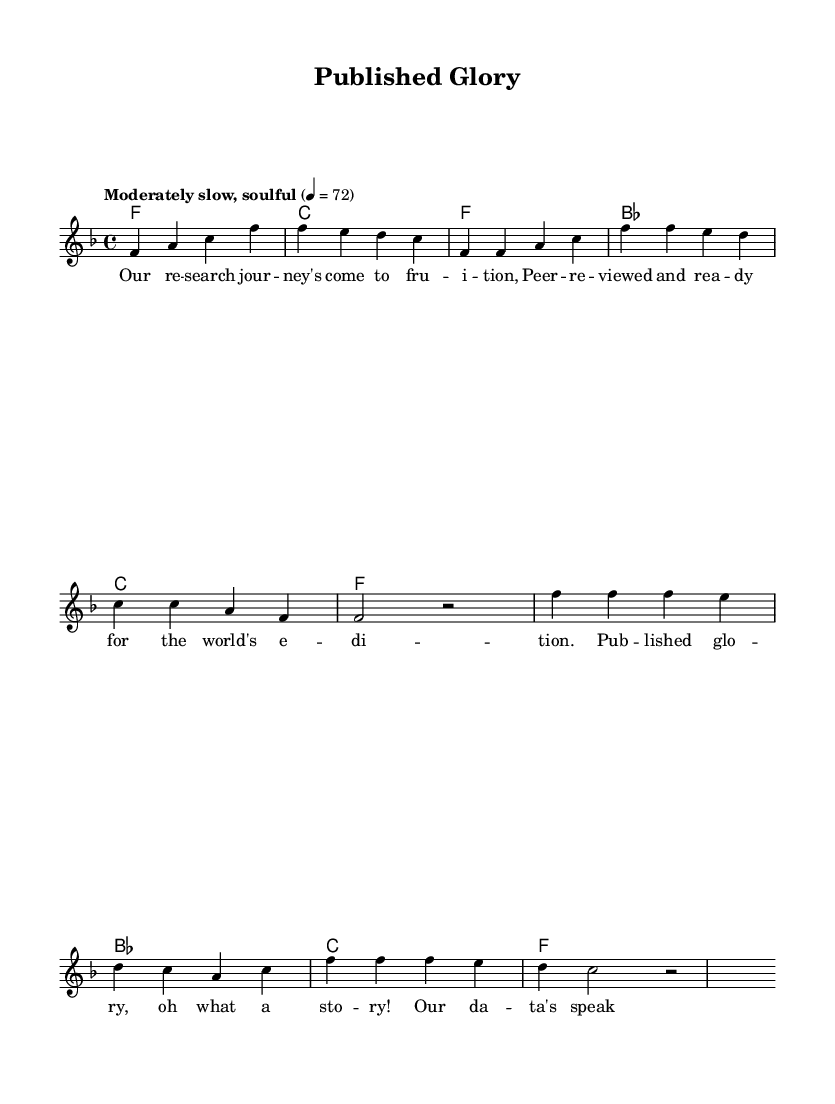What is the key signature of this music? The key signature is F major, indicated by a single flat (B flat) on the staff.
Answer: F major What is the time signature? The time signature is 4/4, meaning there are four beats in each measure.
Answer: 4/4 What is the tempo marking? The tempo marking states "Moderately slow, soulful," which suggests a relaxed but soulful pace for the music.
Answer: Moderately slow, soulful How many measures are in the chorus section? In the sheet music, the chorus consists of two measures as indicated in the corresponding section.
Answer: 2 measures Which chord follows the first measure of the verse? The chord that follows the first measure of the verse is B flat major, which is indicated next in the harmonies.
Answer: B flat major What is the main theme of the lyrics? The main theme of the lyrics revolves around achieving publication and the joy of successful research, as seen in phrases expressing celebrate glory and knowledge gained.
Answer: Published glory How many times does the word "published" appear in the lyrics? The word "published" appears once in the chorus, which expresses the glory of achieving publication.
Answer: Once 